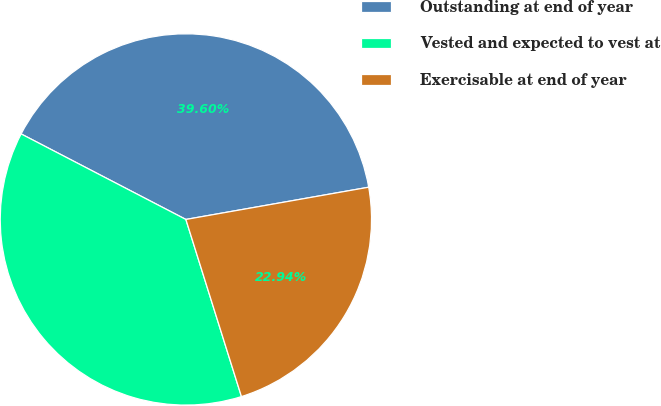Convert chart to OTSL. <chart><loc_0><loc_0><loc_500><loc_500><pie_chart><fcel>Outstanding at end of year<fcel>Vested and expected to vest at<fcel>Exercisable at end of year<nl><fcel>39.6%<fcel>37.46%<fcel>22.94%<nl></chart> 